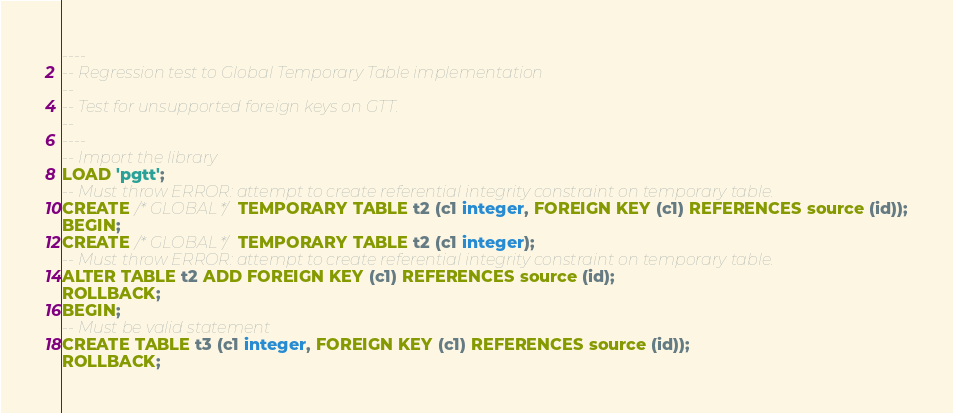Convert code to text. <code><loc_0><loc_0><loc_500><loc_500><_SQL_>----
-- Regression test to Global Temporary Table implementation
--
-- Test for unsupported foreign keys on GTT.
--
----
-- Import the library
LOAD 'pgtt';
-- Must throw ERROR: attempt to create referential integrity constraint on temporary table.
CREATE /*GLOBAL*/ TEMPORARY TABLE t2 (c1 integer, FOREIGN KEY (c1) REFERENCES source (id));
BEGIN;
CREATE /*GLOBAL*/ TEMPORARY TABLE t2 (c1 integer);
-- Must throw ERROR: attempt to create referential integrity constraint on temporary table.
ALTER TABLE t2 ADD FOREIGN KEY (c1) REFERENCES source (id);
ROLLBACK;
BEGIN;
-- Must be valid statement
CREATE TABLE t3 (c1 integer, FOREIGN KEY (c1) REFERENCES source (id));
ROLLBACK;
</code> 